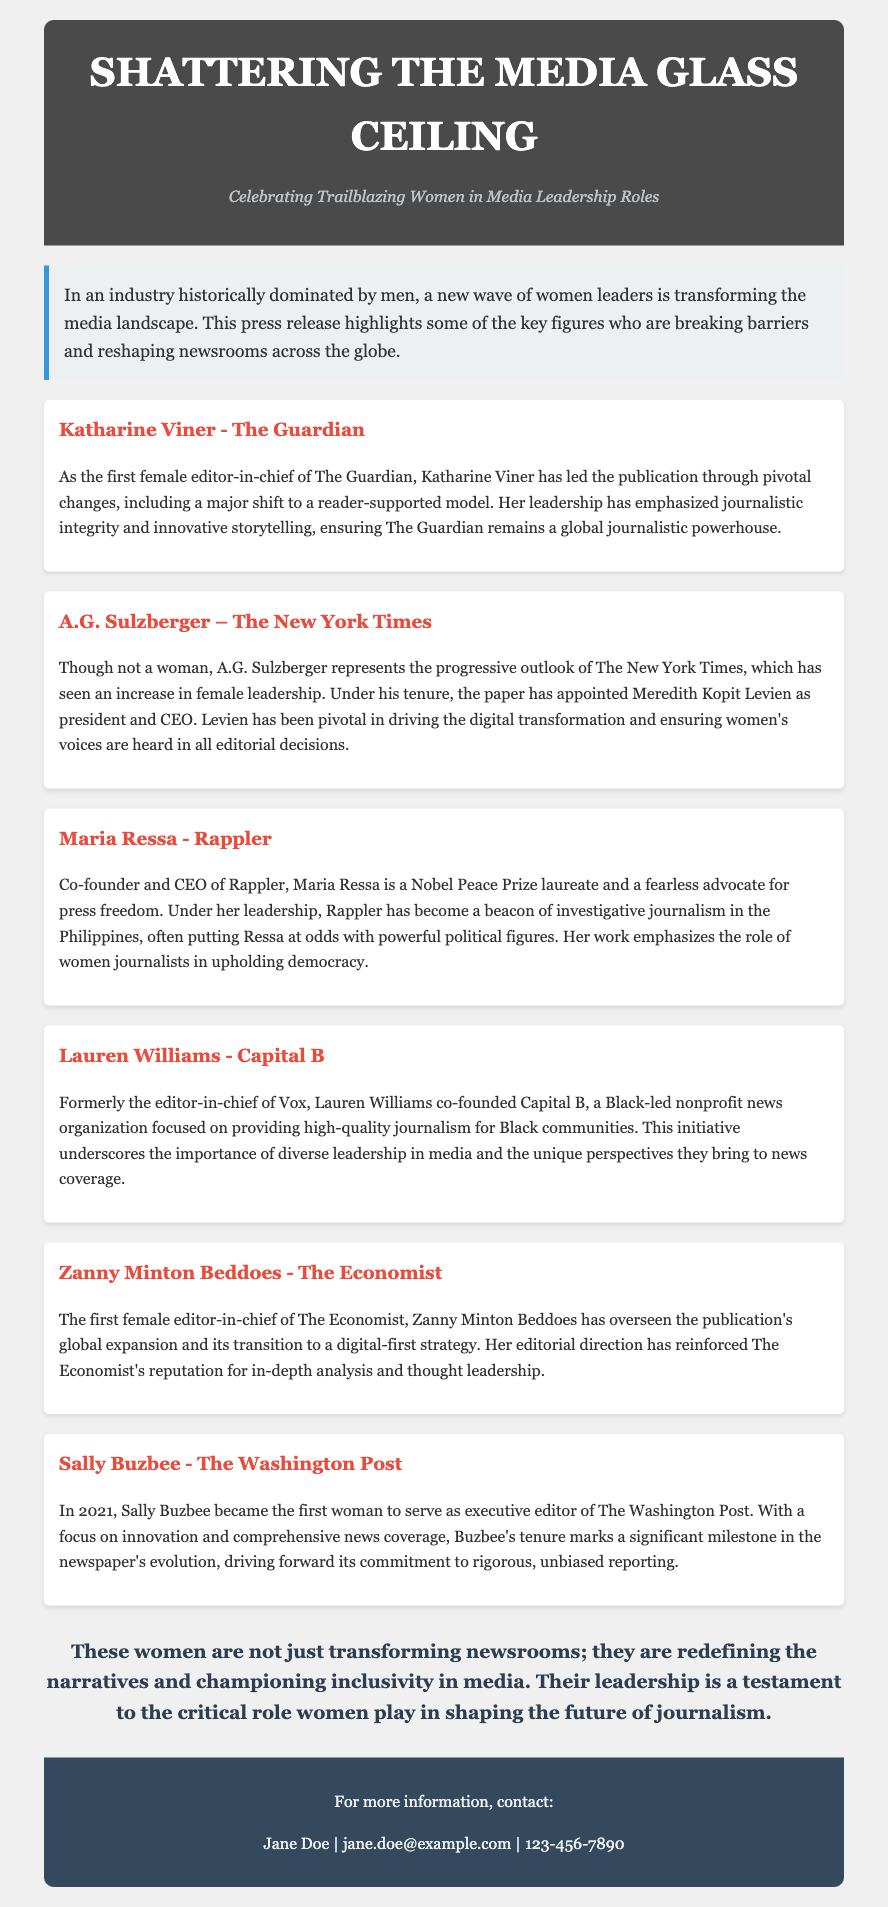What is the title of the press release? The title of the press release is prominently displayed at the top of the document, framing the topic of discussion.
Answer: Shattering the Media Glass Ceiling Who is the first female editor-in-chief of The Guardian? The profile section details the achievements of women leaders in media, specifically mentioning Katharine Viner as the first female editor-in-chief.
Answer: Katharine Viner Which organization did Lauren Williams co-found? The document lists the initiatives of various women leaders in media, noting that Lauren Williams co-founded a specific nonprofit news organization.
Answer: Capital B What significant role does Maria Ressa hold? The press release highlights the accomplishments of Maria Ressa, emphasizing her position within her organization.
Answer: Co-founder and CEO Who became the executive editor of The Washington Post in 2021? The timeline within the document references the appointment of a key figure to a leadership position at a major newspaper.
Answer: Sally Buzbee Which publication is Zanny Minton Beddoes associated with? The profiles identify each woman with their respective publication, detailing Zanny Minton Beddoes's prominent role as editor-in-chief.
Answer: The Economist What does A.G. Sulzberger represent in the context of female leadership? This question involves understanding the broader implications of leadership dynamics within a key media outlet.
Answer: Progressive outlook What is the main theme of this press release? The introductory section of the document outlines the focus of the press release and the societal impact it intends to highlight, particularly regarding women's roles.
Answer: Celebrating Trailblazing Women in Media Leadership Roles 